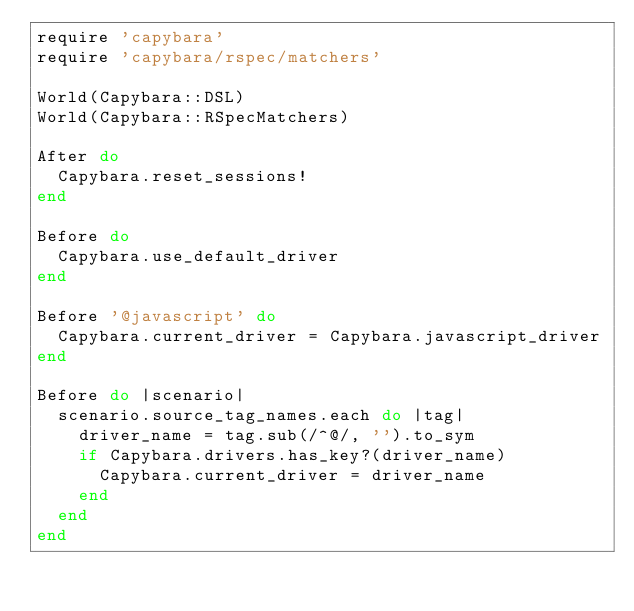Convert code to text. <code><loc_0><loc_0><loc_500><loc_500><_Ruby_>require 'capybara'
require 'capybara/rspec/matchers'

World(Capybara::DSL)
World(Capybara::RSpecMatchers)

After do
  Capybara.reset_sessions!
end

Before do
  Capybara.use_default_driver
end

Before '@javascript' do
  Capybara.current_driver = Capybara.javascript_driver
end

Before do |scenario|
  scenario.source_tag_names.each do |tag|
    driver_name = tag.sub(/^@/, '').to_sym
    if Capybara.drivers.has_key?(driver_name)
      Capybara.current_driver = driver_name
    end
  end
end
</code> 